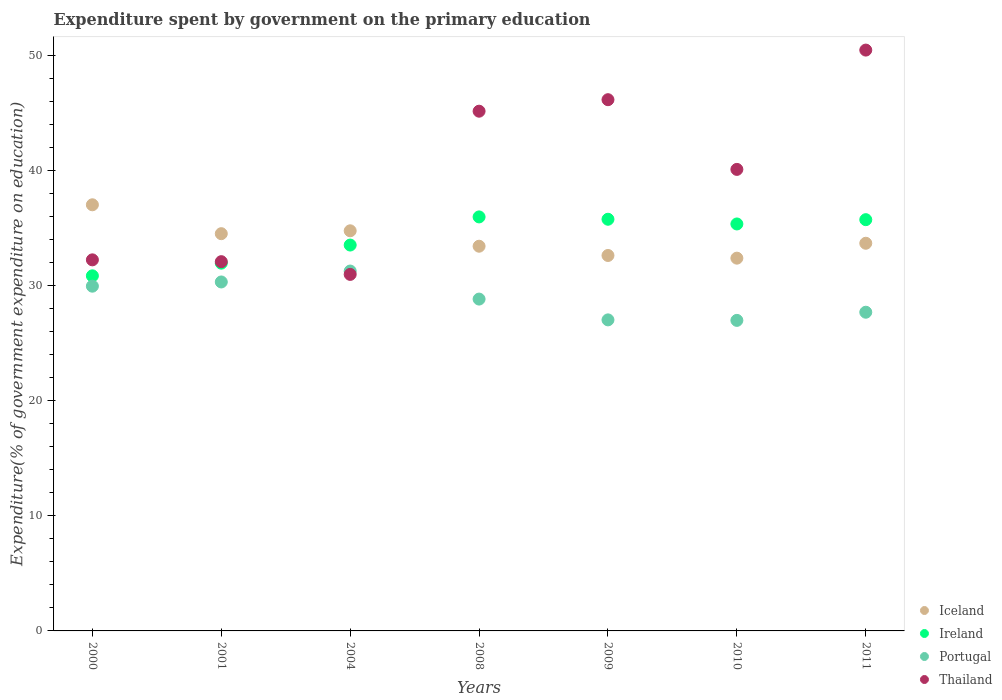What is the expenditure spent by government on the primary education in Ireland in 2004?
Offer a terse response. 33.51. Across all years, what is the maximum expenditure spent by government on the primary education in Iceland?
Your answer should be very brief. 37.01. Across all years, what is the minimum expenditure spent by government on the primary education in Thailand?
Ensure brevity in your answer.  30.97. In which year was the expenditure spent by government on the primary education in Iceland minimum?
Offer a terse response. 2010. What is the total expenditure spent by government on the primary education in Iceland in the graph?
Keep it short and to the point. 238.33. What is the difference between the expenditure spent by government on the primary education in Ireland in 2009 and that in 2010?
Your response must be concise. 0.41. What is the difference between the expenditure spent by government on the primary education in Portugal in 2009 and the expenditure spent by government on the primary education in Ireland in 2008?
Provide a short and direct response. -8.94. What is the average expenditure spent by government on the primary education in Portugal per year?
Your response must be concise. 28.86. In the year 2010, what is the difference between the expenditure spent by government on the primary education in Ireland and expenditure spent by government on the primary education in Thailand?
Provide a short and direct response. -4.74. What is the ratio of the expenditure spent by government on the primary education in Thailand in 2000 to that in 2008?
Make the answer very short. 0.71. Is the expenditure spent by government on the primary education in Portugal in 2000 less than that in 2008?
Offer a terse response. No. What is the difference between the highest and the second highest expenditure spent by government on the primary education in Ireland?
Your answer should be compact. 0.2. What is the difference between the highest and the lowest expenditure spent by government on the primary education in Thailand?
Offer a terse response. 19.48. In how many years, is the expenditure spent by government on the primary education in Ireland greater than the average expenditure spent by government on the primary education in Ireland taken over all years?
Your answer should be very brief. 4. Is the expenditure spent by government on the primary education in Iceland strictly greater than the expenditure spent by government on the primary education in Thailand over the years?
Keep it short and to the point. No. How many years are there in the graph?
Give a very brief answer. 7. Does the graph contain any zero values?
Your answer should be compact. No. Does the graph contain grids?
Provide a succinct answer. No. Where does the legend appear in the graph?
Your answer should be compact. Bottom right. How many legend labels are there?
Your answer should be very brief. 4. What is the title of the graph?
Keep it short and to the point. Expenditure spent by government on the primary education. Does "Romania" appear as one of the legend labels in the graph?
Provide a short and direct response. No. What is the label or title of the Y-axis?
Your answer should be compact. Expenditure(% of government expenditure on education). What is the Expenditure(% of government expenditure on education) in Iceland in 2000?
Offer a terse response. 37.01. What is the Expenditure(% of government expenditure on education) of Ireland in 2000?
Make the answer very short. 30.84. What is the Expenditure(% of government expenditure on education) in Portugal in 2000?
Provide a succinct answer. 29.94. What is the Expenditure(% of government expenditure on education) in Thailand in 2000?
Ensure brevity in your answer.  32.23. What is the Expenditure(% of government expenditure on education) in Iceland in 2001?
Ensure brevity in your answer.  34.5. What is the Expenditure(% of government expenditure on education) in Ireland in 2001?
Provide a succinct answer. 31.94. What is the Expenditure(% of government expenditure on education) of Portugal in 2001?
Your answer should be compact. 30.31. What is the Expenditure(% of government expenditure on education) of Thailand in 2001?
Provide a succinct answer. 32.07. What is the Expenditure(% of government expenditure on education) of Iceland in 2004?
Provide a succinct answer. 34.75. What is the Expenditure(% of government expenditure on education) in Ireland in 2004?
Make the answer very short. 33.51. What is the Expenditure(% of government expenditure on education) in Portugal in 2004?
Keep it short and to the point. 31.26. What is the Expenditure(% of government expenditure on education) in Thailand in 2004?
Offer a terse response. 30.97. What is the Expenditure(% of government expenditure on education) of Iceland in 2008?
Provide a short and direct response. 33.41. What is the Expenditure(% of government expenditure on education) of Ireland in 2008?
Your answer should be compact. 35.96. What is the Expenditure(% of government expenditure on education) of Portugal in 2008?
Provide a succinct answer. 28.82. What is the Expenditure(% of government expenditure on education) of Thailand in 2008?
Make the answer very short. 45.14. What is the Expenditure(% of government expenditure on education) in Iceland in 2009?
Offer a very short reply. 32.61. What is the Expenditure(% of government expenditure on education) in Ireland in 2009?
Offer a very short reply. 35.75. What is the Expenditure(% of government expenditure on education) of Portugal in 2009?
Your answer should be compact. 27.02. What is the Expenditure(% of government expenditure on education) of Thailand in 2009?
Make the answer very short. 46.14. What is the Expenditure(% of government expenditure on education) in Iceland in 2010?
Your answer should be compact. 32.38. What is the Expenditure(% of government expenditure on education) of Ireland in 2010?
Keep it short and to the point. 35.35. What is the Expenditure(% of government expenditure on education) of Portugal in 2010?
Offer a very short reply. 26.97. What is the Expenditure(% of government expenditure on education) of Thailand in 2010?
Offer a very short reply. 40.08. What is the Expenditure(% of government expenditure on education) in Iceland in 2011?
Provide a short and direct response. 33.67. What is the Expenditure(% of government expenditure on education) in Ireland in 2011?
Provide a succinct answer. 35.72. What is the Expenditure(% of government expenditure on education) in Portugal in 2011?
Your response must be concise. 27.68. What is the Expenditure(% of government expenditure on education) in Thailand in 2011?
Offer a terse response. 50.45. Across all years, what is the maximum Expenditure(% of government expenditure on education) in Iceland?
Your answer should be very brief. 37.01. Across all years, what is the maximum Expenditure(% of government expenditure on education) of Ireland?
Make the answer very short. 35.96. Across all years, what is the maximum Expenditure(% of government expenditure on education) in Portugal?
Provide a short and direct response. 31.26. Across all years, what is the maximum Expenditure(% of government expenditure on education) of Thailand?
Your answer should be compact. 50.45. Across all years, what is the minimum Expenditure(% of government expenditure on education) in Iceland?
Your answer should be very brief. 32.38. Across all years, what is the minimum Expenditure(% of government expenditure on education) in Ireland?
Your response must be concise. 30.84. Across all years, what is the minimum Expenditure(% of government expenditure on education) in Portugal?
Keep it short and to the point. 26.97. Across all years, what is the minimum Expenditure(% of government expenditure on education) in Thailand?
Offer a terse response. 30.97. What is the total Expenditure(% of government expenditure on education) in Iceland in the graph?
Make the answer very short. 238.33. What is the total Expenditure(% of government expenditure on education) in Ireland in the graph?
Your answer should be very brief. 239.07. What is the total Expenditure(% of government expenditure on education) in Portugal in the graph?
Your answer should be compact. 201.99. What is the total Expenditure(% of government expenditure on education) of Thailand in the graph?
Make the answer very short. 277.07. What is the difference between the Expenditure(% of government expenditure on education) in Iceland in 2000 and that in 2001?
Your answer should be very brief. 2.51. What is the difference between the Expenditure(% of government expenditure on education) in Ireland in 2000 and that in 2001?
Provide a succinct answer. -1.1. What is the difference between the Expenditure(% of government expenditure on education) of Portugal in 2000 and that in 2001?
Your answer should be compact. -0.37. What is the difference between the Expenditure(% of government expenditure on education) of Thailand in 2000 and that in 2001?
Your response must be concise. 0.16. What is the difference between the Expenditure(% of government expenditure on education) of Iceland in 2000 and that in 2004?
Provide a succinct answer. 2.26. What is the difference between the Expenditure(% of government expenditure on education) in Ireland in 2000 and that in 2004?
Offer a terse response. -2.67. What is the difference between the Expenditure(% of government expenditure on education) in Portugal in 2000 and that in 2004?
Your response must be concise. -1.31. What is the difference between the Expenditure(% of government expenditure on education) in Thailand in 2000 and that in 2004?
Offer a very short reply. 1.26. What is the difference between the Expenditure(% of government expenditure on education) of Iceland in 2000 and that in 2008?
Ensure brevity in your answer.  3.6. What is the difference between the Expenditure(% of government expenditure on education) of Ireland in 2000 and that in 2008?
Offer a very short reply. -5.12. What is the difference between the Expenditure(% of government expenditure on education) of Portugal in 2000 and that in 2008?
Offer a very short reply. 1.12. What is the difference between the Expenditure(% of government expenditure on education) in Thailand in 2000 and that in 2008?
Give a very brief answer. -12.91. What is the difference between the Expenditure(% of government expenditure on education) in Iceland in 2000 and that in 2009?
Offer a very short reply. 4.4. What is the difference between the Expenditure(% of government expenditure on education) in Ireland in 2000 and that in 2009?
Provide a succinct answer. -4.91. What is the difference between the Expenditure(% of government expenditure on education) of Portugal in 2000 and that in 2009?
Make the answer very short. 2.93. What is the difference between the Expenditure(% of government expenditure on education) in Thailand in 2000 and that in 2009?
Your answer should be compact. -13.91. What is the difference between the Expenditure(% of government expenditure on education) in Iceland in 2000 and that in 2010?
Provide a short and direct response. 4.64. What is the difference between the Expenditure(% of government expenditure on education) in Ireland in 2000 and that in 2010?
Make the answer very short. -4.5. What is the difference between the Expenditure(% of government expenditure on education) in Portugal in 2000 and that in 2010?
Provide a succinct answer. 2.97. What is the difference between the Expenditure(% of government expenditure on education) of Thailand in 2000 and that in 2010?
Your answer should be compact. -7.86. What is the difference between the Expenditure(% of government expenditure on education) in Iceland in 2000 and that in 2011?
Offer a very short reply. 3.34. What is the difference between the Expenditure(% of government expenditure on education) of Ireland in 2000 and that in 2011?
Provide a succinct answer. -4.88. What is the difference between the Expenditure(% of government expenditure on education) in Portugal in 2000 and that in 2011?
Offer a terse response. 2.26. What is the difference between the Expenditure(% of government expenditure on education) of Thailand in 2000 and that in 2011?
Your response must be concise. -18.22. What is the difference between the Expenditure(% of government expenditure on education) of Iceland in 2001 and that in 2004?
Keep it short and to the point. -0.25. What is the difference between the Expenditure(% of government expenditure on education) in Ireland in 2001 and that in 2004?
Offer a very short reply. -1.57. What is the difference between the Expenditure(% of government expenditure on education) in Portugal in 2001 and that in 2004?
Offer a very short reply. -0.95. What is the difference between the Expenditure(% of government expenditure on education) in Thailand in 2001 and that in 2004?
Make the answer very short. 1.11. What is the difference between the Expenditure(% of government expenditure on education) of Iceland in 2001 and that in 2008?
Your answer should be compact. 1.09. What is the difference between the Expenditure(% of government expenditure on education) in Ireland in 2001 and that in 2008?
Your answer should be very brief. -4.02. What is the difference between the Expenditure(% of government expenditure on education) in Portugal in 2001 and that in 2008?
Offer a terse response. 1.49. What is the difference between the Expenditure(% of government expenditure on education) of Thailand in 2001 and that in 2008?
Your response must be concise. -13.07. What is the difference between the Expenditure(% of government expenditure on education) of Iceland in 2001 and that in 2009?
Your answer should be compact. 1.89. What is the difference between the Expenditure(% of government expenditure on education) of Ireland in 2001 and that in 2009?
Give a very brief answer. -3.81. What is the difference between the Expenditure(% of government expenditure on education) of Portugal in 2001 and that in 2009?
Your answer should be very brief. 3.29. What is the difference between the Expenditure(% of government expenditure on education) of Thailand in 2001 and that in 2009?
Keep it short and to the point. -14.07. What is the difference between the Expenditure(% of government expenditure on education) of Iceland in 2001 and that in 2010?
Keep it short and to the point. 2.13. What is the difference between the Expenditure(% of government expenditure on education) of Ireland in 2001 and that in 2010?
Make the answer very short. -3.4. What is the difference between the Expenditure(% of government expenditure on education) in Portugal in 2001 and that in 2010?
Offer a very short reply. 3.34. What is the difference between the Expenditure(% of government expenditure on education) of Thailand in 2001 and that in 2010?
Make the answer very short. -8.01. What is the difference between the Expenditure(% of government expenditure on education) in Iceland in 2001 and that in 2011?
Provide a short and direct response. 0.83. What is the difference between the Expenditure(% of government expenditure on education) of Ireland in 2001 and that in 2011?
Keep it short and to the point. -3.78. What is the difference between the Expenditure(% of government expenditure on education) of Portugal in 2001 and that in 2011?
Provide a short and direct response. 2.63. What is the difference between the Expenditure(% of government expenditure on education) of Thailand in 2001 and that in 2011?
Offer a terse response. -18.38. What is the difference between the Expenditure(% of government expenditure on education) of Iceland in 2004 and that in 2008?
Your response must be concise. 1.34. What is the difference between the Expenditure(% of government expenditure on education) of Ireland in 2004 and that in 2008?
Provide a short and direct response. -2.44. What is the difference between the Expenditure(% of government expenditure on education) in Portugal in 2004 and that in 2008?
Give a very brief answer. 2.44. What is the difference between the Expenditure(% of government expenditure on education) of Thailand in 2004 and that in 2008?
Provide a succinct answer. -14.17. What is the difference between the Expenditure(% of government expenditure on education) in Iceland in 2004 and that in 2009?
Your answer should be compact. 2.14. What is the difference between the Expenditure(% of government expenditure on education) of Ireland in 2004 and that in 2009?
Your response must be concise. -2.24. What is the difference between the Expenditure(% of government expenditure on education) in Portugal in 2004 and that in 2009?
Give a very brief answer. 4.24. What is the difference between the Expenditure(% of government expenditure on education) of Thailand in 2004 and that in 2009?
Your answer should be compact. -15.17. What is the difference between the Expenditure(% of government expenditure on education) in Iceland in 2004 and that in 2010?
Keep it short and to the point. 2.38. What is the difference between the Expenditure(% of government expenditure on education) of Ireland in 2004 and that in 2010?
Provide a short and direct response. -1.83. What is the difference between the Expenditure(% of government expenditure on education) of Portugal in 2004 and that in 2010?
Keep it short and to the point. 4.29. What is the difference between the Expenditure(% of government expenditure on education) in Thailand in 2004 and that in 2010?
Your answer should be very brief. -9.12. What is the difference between the Expenditure(% of government expenditure on education) of Iceland in 2004 and that in 2011?
Your response must be concise. 1.08. What is the difference between the Expenditure(% of government expenditure on education) of Ireland in 2004 and that in 2011?
Offer a terse response. -2.2. What is the difference between the Expenditure(% of government expenditure on education) of Portugal in 2004 and that in 2011?
Provide a succinct answer. 3.58. What is the difference between the Expenditure(% of government expenditure on education) in Thailand in 2004 and that in 2011?
Your response must be concise. -19.48. What is the difference between the Expenditure(% of government expenditure on education) in Iceland in 2008 and that in 2009?
Make the answer very short. 0.8. What is the difference between the Expenditure(% of government expenditure on education) in Ireland in 2008 and that in 2009?
Your response must be concise. 0.2. What is the difference between the Expenditure(% of government expenditure on education) of Portugal in 2008 and that in 2009?
Keep it short and to the point. 1.81. What is the difference between the Expenditure(% of government expenditure on education) in Thailand in 2008 and that in 2009?
Offer a very short reply. -1. What is the difference between the Expenditure(% of government expenditure on education) in Iceland in 2008 and that in 2010?
Ensure brevity in your answer.  1.04. What is the difference between the Expenditure(% of government expenditure on education) in Ireland in 2008 and that in 2010?
Keep it short and to the point. 0.61. What is the difference between the Expenditure(% of government expenditure on education) in Portugal in 2008 and that in 2010?
Offer a terse response. 1.85. What is the difference between the Expenditure(% of government expenditure on education) in Thailand in 2008 and that in 2010?
Make the answer very short. 5.05. What is the difference between the Expenditure(% of government expenditure on education) in Iceland in 2008 and that in 2011?
Your response must be concise. -0.26. What is the difference between the Expenditure(% of government expenditure on education) of Ireland in 2008 and that in 2011?
Your answer should be very brief. 0.24. What is the difference between the Expenditure(% of government expenditure on education) of Portugal in 2008 and that in 2011?
Offer a terse response. 1.14. What is the difference between the Expenditure(% of government expenditure on education) of Thailand in 2008 and that in 2011?
Offer a terse response. -5.31. What is the difference between the Expenditure(% of government expenditure on education) of Iceland in 2009 and that in 2010?
Make the answer very short. 0.23. What is the difference between the Expenditure(% of government expenditure on education) of Ireland in 2009 and that in 2010?
Give a very brief answer. 0.41. What is the difference between the Expenditure(% of government expenditure on education) in Portugal in 2009 and that in 2010?
Your response must be concise. 0.04. What is the difference between the Expenditure(% of government expenditure on education) in Thailand in 2009 and that in 2010?
Provide a short and direct response. 6.05. What is the difference between the Expenditure(% of government expenditure on education) of Iceland in 2009 and that in 2011?
Ensure brevity in your answer.  -1.06. What is the difference between the Expenditure(% of government expenditure on education) of Ireland in 2009 and that in 2011?
Provide a short and direct response. 0.04. What is the difference between the Expenditure(% of government expenditure on education) in Portugal in 2009 and that in 2011?
Make the answer very short. -0.66. What is the difference between the Expenditure(% of government expenditure on education) of Thailand in 2009 and that in 2011?
Give a very brief answer. -4.31. What is the difference between the Expenditure(% of government expenditure on education) of Iceland in 2010 and that in 2011?
Offer a very short reply. -1.29. What is the difference between the Expenditure(% of government expenditure on education) of Ireland in 2010 and that in 2011?
Offer a terse response. -0.37. What is the difference between the Expenditure(% of government expenditure on education) in Portugal in 2010 and that in 2011?
Provide a short and direct response. -0.71. What is the difference between the Expenditure(% of government expenditure on education) of Thailand in 2010 and that in 2011?
Keep it short and to the point. -10.36. What is the difference between the Expenditure(% of government expenditure on education) in Iceland in 2000 and the Expenditure(% of government expenditure on education) in Ireland in 2001?
Give a very brief answer. 5.07. What is the difference between the Expenditure(% of government expenditure on education) of Iceland in 2000 and the Expenditure(% of government expenditure on education) of Portugal in 2001?
Provide a succinct answer. 6.7. What is the difference between the Expenditure(% of government expenditure on education) of Iceland in 2000 and the Expenditure(% of government expenditure on education) of Thailand in 2001?
Offer a terse response. 4.94. What is the difference between the Expenditure(% of government expenditure on education) of Ireland in 2000 and the Expenditure(% of government expenditure on education) of Portugal in 2001?
Offer a terse response. 0.53. What is the difference between the Expenditure(% of government expenditure on education) in Ireland in 2000 and the Expenditure(% of government expenditure on education) in Thailand in 2001?
Provide a short and direct response. -1.23. What is the difference between the Expenditure(% of government expenditure on education) in Portugal in 2000 and the Expenditure(% of government expenditure on education) in Thailand in 2001?
Your answer should be compact. -2.13. What is the difference between the Expenditure(% of government expenditure on education) in Iceland in 2000 and the Expenditure(% of government expenditure on education) in Ireland in 2004?
Offer a very short reply. 3.5. What is the difference between the Expenditure(% of government expenditure on education) of Iceland in 2000 and the Expenditure(% of government expenditure on education) of Portugal in 2004?
Keep it short and to the point. 5.75. What is the difference between the Expenditure(% of government expenditure on education) of Iceland in 2000 and the Expenditure(% of government expenditure on education) of Thailand in 2004?
Keep it short and to the point. 6.05. What is the difference between the Expenditure(% of government expenditure on education) in Ireland in 2000 and the Expenditure(% of government expenditure on education) in Portugal in 2004?
Provide a succinct answer. -0.42. What is the difference between the Expenditure(% of government expenditure on education) of Ireland in 2000 and the Expenditure(% of government expenditure on education) of Thailand in 2004?
Your answer should be very brief. -0.12. What is the difference between the Expenditure(% of government expenditure on education) in Portugal in 2000 and the Expenditure(% of government expenditure on education) in Thailand in 2004?
Your answer should be compact. -1.02. What is the difference between the Expenditure(% of government expenditure on education) in Iceland in 2000 and the Expenditure(% of government expenditure on education) in Ireland in 2008?
Ensure brevity in your answer.  1.05. What is the difference between the Expenditure(% of government expenditure on education) of Iceland in 2000 and the Expenditure(% of government expenditure on education) of Portugal in 2008?
Your answer should be very brief. 8.19. What is the difference between the Expenditure(% of government expenditure on education) in Iceland in 2000 and the Expenditure(% of government expenditure on education) in Thailand in 2008?
Offer a very short reply. -8.13. What is the difference between the Expenditure(% of government expenditure on education) of Ireland in 2000 and the Expenditure(% of government expenditure on education) of Portugal in 2008?
Make the answer very short. 2.02. What is the difference between the Expenditure(% of government expenditure on education) in Ireland in 2000 and the Expenditure(% of government expenditure on education) in Thailand in 2008?
Keep it short and to the point. -14.3. What is the difference between the Expenditure(% of government expenditure on education) of Portugal in 2000 and the Expenditure(% of government expenditure on education) of Thailand in 2008?
Your response must be concise. -15.2. What is the difference between the Expenditure(% of government expenditure on education) of Iceland in 2000 and the Expenditure(% of government expenditure on education) of Ireland in 2009?
Keep it short and to the point. 1.26. What is the difference between the Expenditure(% of government expenditure on education) of Iceland in 2000 and the Expenditure(% of government expenditure on education) of Portugal in 2009?
Your response must be concise. 10. What is the difference between the Expenditure(% of government expenditure on education) of Iceland in 2000 and the Expenditure(% of government expenditure on education) of Thailand in 2009?
Offer a very short reply. -9.13. What is the difference between the Expenditure(% of government expenditure on education) in Ireland in 2000 and the Expenditure(% of government expenditure on education) in Portugal in 2009?
Give a very brief answer. 3.83. What is the difference between the Expenditure(% of government expenditure on education) of Ireland in 2000 and the Expenditure(% of government expenditure on education) of Thailand in 2009?
Provide a succinct answer. -15.3. What is the difference between the Expenditure(% of government expenditure on education) of Portugal in 2000 and the Expenditure(% of government expenditure on education) of Thailand in 2009?
Keep it short and to the point. -16.2. What is the difference between the Expenditure(% of government expenditure on education) in Iceland in 2000 and the Expenditure(% of government expenditure on education) in Ireland in 2010?
Your answer should be compact. 1.67. What is the difference between the Expenditure(% of government expenditure on education) of Iceland in 2000 and the Expenditure(% of government expenditure on education) of Portugal in 2010?
Keep it short and to the point. 10.04. What is the difference between the Expenditure(% of government expenditure on education) of Iceland in 2000 and the Expenditure(% of government expenditure on education) of Thailand in 2010?
Your answer should be compact. -3.07. What is the difference between the Expenditure(% of government expenditure on education) of Ireland in 2000 and the Expenditure(% of government expenditure on education) of Portugal in 2010?
Your answer should be compact. 3.87. What is the difference between the Expenditure(% of government expenditure on education) in Ireland in 2000 and the Expenditure(% of government expenditure on education) in Thailand in 2010?
Keep it short and to the point. -9.24. What is the difference between the Expenditure(% of government expenditure on education) of Portugal in 2000 and the Expenditure(% of government expenditure on education) of Thailand in 2010?
Your answer should be very brief. -10.14. What is the difference between the Expenditure(% of government expenditure on education) of Iceland in 2000 and the Expenditure(% of government expenditure on education) of Ireland in 2011?
Your answer should be compact. 1.29. What is the difference between the Expenditure(% of government expenditure on education) of Iceland in 2000 and the Expenditure(% of government expenditure on education) of Portugal in 2011?
Keep it short and to the point. 9.33. What is the difference between the Expenditure(% of government expenditure on education) in Iceland in 2000 and the Expenditure(% of government expenditure on education) in Thailand in 2011?
Your response must be concise. -13.44. What is the difference between the Expenditure(% of government expenditure on education) in Ireland in 2000 and the Expenditure(% of government expenditure on education) in Portugal in 2011?
Give a very brief answer. 3.16. What is the difference between the Expenditure(% of government expenditure on education) in Ireland in 2000 and the Expenditure(% of government expenditure on education) in Thailand in 2011?
Keep it short and to the point. -19.61. What is the difference between the Expenditure(% of government expenditure on education) in Portugal in 2000 and the Expenditure(% of government expenditure on education) in Thailand in 2011?
Keep it short and to the point. -20.5. What is the difference between the Expenditure(% of government expenditure on education) of Iceland in 2001 and the Expenditure(% of government expenditure on education) of Ireland in 2004?
Your response must be concise. 0.99. What is the difference between the Expenditure(% of government expenditure on education) in Iceland in 2001 and the Expenditure(% of government expenditure on education) in Portugal in 2004?
Offer a terse response. 3.25. What is the difference between the Expenditure(% of government expenditure on education) in Iceland in 2001 and the Expenditure(% of government expenditure on education) in Thailand in 2004?
Make the answer very short. 3.54. What is the difference between the Expenditure(% of government expenditure on education) of Ireland in 2001 and the Expenditure(% of government expenditure on education) of Portugal in 2004?
Your answer should be compact. 0.68. What is the difference between the Expenditure(% of government expenditure on education) of Ireland in 2001 and the Expenditure(% of government expenditure on education) of Thailand in 2004?
Your response must be concise. 0.98. What is the difference between the Expenditure(% of government expenditure on education) in Portugal in 2001 and the Expenditure(% of government expenditure on education) in Thailand in 2004?
Make the answer very short. -0.66. What is the difference between the Expenditure(% of government expenditure on education) of Iceland in 2001 and the Expenditure(% of government expenditure on education) of Ireland in 2008?
Provide a succinct answer. -1.46. What is the difference between the Expenditure(% of government expenditure on education) in Iceland in 2001 and the Expenditure(% of government expenditure on education) in Portugal in 2008?
Ensure brevity in your answer.  5.68. What is the difference between the Expenditure(% of government expenditure on education) of Iceland in 2001 and the Expenditure(% of government expenditure on education) of Thailand in 2008?
Give a very brief answer. -10.64. What is the difference between the Expenditure(% of government expenditure on education) in Ireland in 2001 and the Expenditure(% of government expenditure on education) in Portugal in 2008?
Your answer should be very brief. 3.12. What is the difference between the Expenditure(% of government expenditure on education) in Ireland in 2001 and the Expenditure(% of government expenditure on education) in Thailand in 2008?
Keep it short and to the point. -13.2. What is the difference between the Expenditure(% of government expenditure on education) in Portugal in 2001 and the Expenditure(% of government expenditure on education) in Thailand in 2008?
Your answer should be compact. -14.83. What is the difference between the Expenditure(% of government expenditure on education) in Iceland in 2001 and the Expenditure(% of government expenditure on education) in Ireland in 2009?
Provide a succinct answer. -1.25. What is the difference between the Expenditure(% of government expenditure on education) of Iceland in 2001 and the Expenditure(% of government expenditure on education) of Portugal in 2009?
Make the answer very short. 7.49. What is the difference between the Expenditure(% of government expenditure on education) in Iceland in 2001 and the Expenditure(% of government expenditure on education) in Thailand in 2009?
Provide a succinct answer. -11.64. What is the difference between the Expenditure(% of government expenditure on education) of Ireland in 2001 and the Expenditure(% of government expenditure on education) of Portugal in 2009?
Offer a very short reply. 4.93. What is the difference between the Expenditure(% of government expenditure on education) of Ireland in 2001 and the Expenditure(% of government expenditure on education) of Thailand in 2009?
Make the answer very short. -14.2. What is the difference between the Expenditure(% of government expenditure on education) in Portugal in 2001 and the Expenditure(% of government expenditure on education) in Thailand in 2009?
Provide a succinct answer. -15.83. What is the difference between the Expenditure(% of government expenditure on education) of Iceland in 2001 and the Expenditure(% of government expenditure on education) of Ireland in 2010?
Your response must be concise. -0.84. What is the difference between the Expenditure(% of government expenditure on education) of Iceland in 2001 and the Expenditure(% of government expenditure on education) of Portugal in 2010?
Provide a short and direct response. 7.53. What is the difference between the Expenditure(% of government expenditure on education) in Iceland in 2001 and the Expenditure(% of government expenditure on education) in Thailand in 2010?
Give a very brief answer. -5.58. What is the difference between the Expenditure(% of government expenditure on education) in Ireland in 2001 and the Expenditure(% of government expenditure on education) in Portugal in 2010?
Give a very brief answer. 4.97. What is the difference between the Expenditure(% of government expenditure on education) of Ireland in 2001 and the Expenditure(% of government expenditure on education) of Thailand in 2010?
Make the answer very short. -8.14. What is the difference between the Expenditure(% of government expenditure on education) in Portugal in 2001 and the Expenditure(% of government expenditure on education) in Thailand in 2010?
Your answer should be compact. -9.78. What is the difference between the Expenditure(% of government expenditure on education) of Iceland in 2001 and the Expenditure(% of government expenditure on education) of Ireland in 2011?
Your answer should be compact. -1.22. What is the difference between the Expenditure(% of government expenditure on education) of Iceland in 2001 and the Expenditure(% of government expenditure on education) of Portugal in 2011?
Give a very brief answer. 6.82. What is the difference between the Expenditure(% of government expenditure on education) in Iceland in 2001 and the Expenditure(% of government expenditure on education) in Thailand in 2011?
Make the answer very short. -15.95. What is the difference between the Expenditure(% of government expenditure on education) in Ireland in 2001 and the Expenditure(% of government expenditure on education) in Portugal in 2011?
Provide a succinct answer. 4.26. What is the difference between the Expenditure(% of government expenditure on education) of Ireland in 2001 and the Expenditure(% of government expenditure on education) of Thailand in 2011?
Your response must be concise. -18.51. What is the difference between the Expenditure(% of government expenditure on education) of Portugal in 2001 and the Expenditure(% of government expenditure on education) of Thailand in 2011?
Your response must be concise. -20.14. What is the difference between the Expenditure(% of government expenditure on education) of Iceland in 2004 and the Expenditure(% of government expenditure on education) of Ireland in 2008?
Keep it short and to the point. -1.21. What is the difference between the Expenditure(% of government expenditure on education) in Iceland in 2004 and the Expenditure(% of government expenditure on education) in Portugal in 2008?
Keep it short and to the point. 5.93. What is the difference between the Expenditure(% of government expenditure on education) in Iceland in 2004 and the Expenditure(% of government expenditure on education) in Thailand in 2008?
Provide a succinct answer. -10.39. What is the difference between the Expenditure(% of government expenditure on education) of Ireland in 2004 and the Expenditure(% of government expenditure on education) of Portugal in 2008?
Your answer should be very brief. 4.69. What is the difference between the Expenditure(% of government expenditure on education) of Ireland in 2004 and the Expenditure(% of government expenditure on education) of Thailand in 2008?
Offer a terse response. -11.63. What is the difference between the Expenditure(% of government expenditure on education) in Portugal in 2004 and the Expenditure(% of government expenditure on education) in Thailand in 2008?
Make the answer very short. -13.88. What is the difference between the Expenditure(% of government expenditure on education) of Iceland in 2004 and the Expenditure(% of government expenditure on education) of Ireland in 2009?
Provide a short and direct response. -1. What is the difference between the Expenditure(% of government expenditure on education) of Iceland in 2004 and the Expenditure(% of government expenditure on education) of Portugal in 2009?
Offer a very short reply. 7.74. What is the difference between the Expenditure(% of government expenditure on education) in Iceland in 2004 and the Expenditure(% of government expenditure on education) in Thailand in 2009?
Your response must be concise. -11.39. What is the difference between the Expenditure(% of government expenditure on education) in Ireland in 2004 and the Expenditure(% of government expenditure on education) in Portugal in 2009?
Offer a very short reply. 6.5. What is the difference between the Expenditure(% of government expenditure on education) of Ireland in 2004 and the Expenditure(% of government expenditure on education) of Thailand in 2009?
Your answer should be compact. -12.62. What is the difference between the Expenditure(% of government expenditure on education) in Portugal in 2004 and the Expenditure(% of government expenditure on education) in Thailand in 2009?
Keep it short and to the point. -14.88. What is the difference between the Expenditure(% of government expenditure on education) of Iceland in 2004 and the Expenditure(% of government expenditure on education) of Ireland in 2010?
Ensure brevity in your answer.  -0.59. What is the difference between the Expenditure(% of government expenditure on education) in Iceland in 2004 and the Expenditure(% of government expenditure on education) in Portugal in 2010?
Keep it short and to the point. 7.78. What is the difference between the Expenditure(% of government expenditure on education) of Iceland in 2004 and the Expenditure(% of government expenditure on education) of Thailand in 2010?
Make the answer very short. -5.33. What is the difference between the Expenditure(% of government expenditure on education) of Ireland in 2004 and the Expenditure(% of government expenditure on education) of Portugal in 2010?
Keep it short and to the point. 6.54. What is the difference between the Expenditure(% of government expenditure on education) in Ireland in 2004 and the Expenditure(% of government expenditure on education) in Thailand in 2010?
Your answer should be very brief. -6.57. What is the difference between the Expenditure(% of government expenditure on education) in Portugal in 2004 and the Expenditure(% of government expenditure on education) in Thailand in 2010?
Keep it short and to the point. -8.83. What is the difference between the Expenditure(% of government expenditure on education) of Iceland in 2004 and the Expenditure(% of government expenditure on education) of Ireland in 2011?
Provide a short and direct response. -0.97. What is the difference between the Expenditure(% of government expenditure on education) of Iceland in 2004 and the Expenditure(% of government expenditure on education) of Portugal in 2011?
Ensure brevity in your answer.  7.07. What is the difference between the Expenditure(% of government expenditure on education) of Iceland in 2004 and the Expenditure(% of government expenditure on education) of Thailand in 2011?
Your response must be concise. -15.7. What is the difference between the Expenditure(% of government expenditure on education) in Ireland in 2004 and the Expenditure(% of government expenditure on education) in Portugal in 2011?
Offer a terse response. 5.83. What is the difference between the Expenditure(% of government expenditure on education) in Ireland in 2004 and the Expenditure(% of government expenditure on education) in Thailand in 2011?
Give a very brief answer. -16.93. What is the difference between the Expenditure(% of government expenditure on education) in Portugal in 2004 and the Expenditure(% of government expenditure on education) in Thailand in 2011?
Your response must be concise. -19.19. What is the difference between the Expenditure(% of government expenditure on education) in Iceland in 2008 and the Expenditure(% of government expenditure on education) in Ireland in 2009?
Offer a terse response. -2.34. What is the difference between the Expenditure(% of government expenditure on education) of Iceland in 2008 and the Expenditure(% of government expenditure on education) of Portugal in 2009?
Offer a very short reply. 6.4. What is the difference between the Expenditure(% of government expenditure on education) of Iceland in 2008 and the Expenditure(% of government expenditure on education) of Thailand in 2009?
Provide a succinct answer. -12.73. What is the difference between the Expenditure(% of government expenditure on education) of Ireland in 2008 and the Expenditure(% of government expenditure on education) of Portugal in 2009?
Keep it short and to the point. 8.94. What is the difference between the Expenditure(% of government expenditure on education) of Ireland in 2008 and the Expenditure(% of government expenditure on education) of Thailand in 2009?
Provide a succinct answer. -10.18. What is the difference between the Expenditure(% of government expenditure on education) of Portugal in 2008 and the Expenditure(% of government expenditure on education) of Thailand in 2009?
Offer a terse response. -17.32. What is the difference between the Expenditure(% of government expenditure on education) in Iceland in 2008 and the Expenditure(% of government expenditure on education) in Ireland in 2010?
Offer a terse response. -1.93. What is the difference between the Expenditure(% of government expenditure on education) in Iceland in 2008 and the Expenditure(% of government expenditure on education) in Portugal in 2010?
Your response must be concise. 6.44. What is the difference between the Expenditure(% of government expenditure on education) of Iceland in 2008 and the Expenditure(% of government expenditure on education) of Thailand in 2010?
Give a very brief answer. -6.67. What is the difference between the Expenditure(% of government expenditure on education) in Ireland in 2008 and the Expenditure(% of government expenditure on education) in Portugal in 2010?
Provide a succinct answer. 8.99. What is the difference between the Expenditure(% of government expenditure on education) in Ireland in 2008 and the Expenditure(% of government expenditure on education) in Thailand in 2010?
Give a very brief answer. -4.13. What is the difference between the Expenditure(% of government expenditure on education) in Portugal in 2008 and the Expenditure(% of government expenditure on education) in Thailand in 2010?
Your answer should be compact. -11.26. What is the difference between the Expenditure(% of government expenditure on education) of Iceland in 2008 and the Expenditure(% of government expenditure on education) of Ireland in 2011?
Offer a very short reply. -2.31. What is the difference between the Expenditure(% of government expenditure on education) of Iceland in 2008 and the Expenditure(% of government expenditure on education) of Portugal in 2011?
Ensure brevity in your answer.  5.73. What is the difference between the Expenditure(% of government expenditure on education) in Iceland in 2008 and the Expenditure(% of government expenditure on education) in Thailand in 2011?
Provide a short and direct response. -17.03. What is the difference between the Expenditure(% of government expenditure on education) of Ireland in 2008 and the Expenditure(% of government expenditure on education) of Portugal in 2011?
Provide a short and direct response. 8.28. What is the difference between the Expenditure(% of government expenditure on education) in Ireland in 2008 and the Expenditure(% of government expenditure on education) in Thailand in 2011?
Your answer should be very brief. -14.49. What is the difference between the Expenditure(% of government expenditure on education) of Portugal in 2008 and the Expenditure(% of government expenditure on education) of Thailand in 2011?
Offer a terse response. -21.63. What is the difference between the Expenditure(% of government expenditure on education) of Iceland in 2009 and the Expenditure(% of government expenditure on education) of Ireland in 2010?
Your answer should be very brief. -2.74. What is the difference between the Expenditure(% of government expenditure on education) in Iceland in 2009 and the Expenditure(% of government expenditure on education) in Portugal in 2010?
Your answer should be compact. 5.64. What is the difference between the Expenditure(% of government expenditure on education) in Iceland in 2009 and the Expenditure(% of government expenditure on education) in Thailand in 2010?
Ensure brevity in your answer.  -7.48. What is the difference between the Expenditure(% of government expenditure on education) in Ireland in 2009 and the Expenditure(% of government expenditure on education) in Portugal in 2010?
Give a very brief answer. 8.78. What is the difference between the Expenditure(% of government expenditure on education) of Ireland in 2009 and the Expenditure(% of government expenditure on education) of Thailand in 2010?
Provide a succinct answer. -4.33. What is the difference between the Expenditure(% of government expenditure on education) in Portugal in 2009 and the Expenditure(% of government expenditure on education) in Thailand in 2010?
Provide a short and direct response. -13.07. What is the difference between the Expenditure(% of government expenditure on education) of Iceland in 2009 and the Expenditure(% of government expenditure on education) of Ireland in 2011?
Your answer should be compact. -3.11. What is the difference between the Expenditure(% of government expenditure on education) in Iceland in 2009 and the Expenditure(% of government expenditure on education) in Portugal in 2011?
Your response must be concise. 4.93. What is the difference between the Expenditure(% of government expenditure on education) in Iceland in 2009 and the Expenditure(% of government expenditure on education) in Thailand in 2011?
Your answer should be compact. -17.84. What is the difference between the Expenditure(% of government expenditure on education) in Ireland in 2009 and the Expenditure(% of government expenditure on education) in Portugal in 2011?
Make the answer very short. 8.07. What is the difference between the Expenditure(% of government expenditure on education) in Ireland in 2009 and the Expenditure(% of government expenditure on education) in Thailand in 2011?
Your response must be concise. -14.69. What is the difference between the Expenditure(% of government expenditure on education) of Portugal in 2009 and the Expenditure(% of government expenditure on education) of Thailand in 2011?
Provide a short and direct response. -23.43. What is the difference between the Expenditure(% of government expenditure on education) in Iceland in 2010 and the Expenditure(% of government expenditure on education) in Ireland in 2011?
Your answer should be compact. -3.34. What is the difference between the Expenditure(% of government expenditure on education) in Iceland in 2010 and the Expenditure(% of government expenditure on education) in Portugal in 2011?
Give a very brief answer. 4.7. What is the difference between the Expenditure(% of government expenditure on education) of Iceland in 2010 and the Expenditure(% of government expenditure on education) of Thailand in 2011?
Your answer should be compact. -18.07. What is the difference between the Expenditure(% of government expenditure on education) in Ireland in 2010 and the Expenditure(% of government expenditure on education) in Portugal in 2011?
Your answer should be compact. 7.67. What is the difference between the Expenditure(% of government expenditure on education) in Ireland in 2010 and the Expenditure(% of government expenditure on education) in Thailand in 2011?
Offer a terse response. -15.1. What is the difference between the Expenditure(% of government expenditure on education) of Portugal in 2010 and the Expenditure(% of government expenditure on education) of Thailand in 2011?
Your answer should be compact. -23.48. What is the average Expenditure(% of government expenditure on education) of Iceland per year?
Make the answer very short. 34.05. What is the average Expenditure(% of government expenditure on education) of Ireland per year?
Offer a very short reply. 34.15. What is the average Expenditure(% of government expenditure on education) of Portugal per year?
Give a very brief answer. 28.86. What is the average Expenditure(% of government expenditure on education) of Thailand per year?
Make the answer very short. 39.58. In the year 2000, what is the difference between the Expenditure(% of government expenditure on education) in Iceland and Expenditure(% of government expenditure on education) in Ireland?
Offer a very short reply. 6.17. In the year 2000, what is the difference between the Expenditure(% of government expenditure on education) in Iceland and Expenditure(% of government expenditure on education) in Portugal?
Offer a terse response. 7.07. In the year 2000, what is the difference between the Expenditure(% of government expenditure on education) of Iceland and Expenditure(% of government expenditure on education) of Thailand?
Offer a terse response. 4.78. In the year 2000, what is the difference between the Expenditure(% of government expenditure on education) of Ireland and Expenditure(% of government expenditure on education) of Portugal?
Your response must be concise. 0.9. In the year 2000, what is the difference between the Expenditure(% of government expenditure on education) in Ireland and Expenditure(% of government expenditure on education) in Thailand?
Your answer should be very brief. -1.39. In the year 2000, what is the difference between the Expenditure(% of government expenditure on education) in Portugal and Expenditure(% of government expenditure on education) in Thailand?
Your response must be concise. -2.29. In the year 2001, what is the difference between the Expenditure(% of government expenditure on education) of Iceland and Expenditure(% of government expenditure on education) of Ireland?
Your answer should be very brief. 2.56. In the year 2001, what is the difference between the Expenditure(% of government expenditure on education) of Iceland and Expenditure(% of government expenditure on education) of Portugal?
Offer a very short reply. 4.19. In the year 2001, what is the difference between the Expenditure(% of government expenditure on education) in Iceland and Expenditure(% of government expenditure on education) in Thailand?
Make the answer very short. 2.43. In the year 2001, what is the difference between the Expenditure(% of government expenditure on education) of Ireland and Expenditure(% of government expenditure on education) of Portugal?
Keep it short and to the point. 1.63. In the year 2001, what is the difference between the Expenditure(% of government expenditure on education) of Ireland and Expenditure(% of government expenditure on education) of Thailand?
Ensure brevity in your answer.  -0.13. In the year 2001, what is the difference between the Expenditure(% of government expenditure on education) in Portugal and Expenditure(% of government expenditure on education) in Thailand?
Give a very brief answer. -1.76. In the year 2004, what is the difference between the Expenditure(% of government expenditure on education) of Iceland and Expenditure(% of government expenditure on education) of Ireland?
Make the answer very short. 1.24. In the year 2004, what is the difference between the Expenditure(% of government expenditure on education) of Iceland and Expenditure(% of government expenditure on education) of Portugal?
Keep it short and to the point. 3.49. In the year 2004, what is the difference between the Expenditure(% of government expenditure on education) in Iceland and Expenditure(% of government expenditure on education) in Thailand?
Give a very brief answer. 3.79. In the year 2004, what is the difference between the Expenditure(% of government expenditure on education) of Ireland and Expenditure(% of government expenditure on education) of Portugal?
Ensure brevity in your answer.  2.26. In the year 2004, what is the difference between the Expenditure(% of government expenditure on education) of Ireland and Expenditure(% of government expenditure on education) of Thailand?
Provide a succinct answer. 2.55. In the year 2004, what is the difference between the Expenditure(% of government expenditure on education) in Portugal and Expenditure(% of government expenditure on education) in Thailand?
Keep it short and to the point. 0.29. In the year 2008, what is the difference between the Expenditure(% of government expenditure on education) in Iceland and Expenditure(% of government expenditure on education) in Ireland?
Provide a short and direct response. -2.55. In the year 2008, what is the difference between the Expenditure(% of government expenditure on education) of Iceland and Expenditure(% of government expenditure on education) of Portugal?
Your answer should be compact. 4.59. In the year 2008, what is the difference between the Expenditure(% of government expenditure on education) in Iceland and Expenditure(% of government expenditure on education) in Thailand?
Your answer should be compact. -11.73. In the year 2008, what is the difference between the Expenditure(% of government expenditure on education) in Ireland and Expenditure(% of government expenditure on education) in Portugal?
Ensure brevity in your answer.  7.14. In the year 2008, what is the difference between the Expenditure(% of government expenditure on education) of Ireland and Expenditure(% of government expenditure on education) of Thailand?
Ensure brevity in your answer.  -9.18. In the year 2008, what is the difference between the Expenditure(% of government expenditure on education) of Portugal and Expenditure(% of government expenditure on education) of Thailand?
Offer a terse response. -16.32. In the year 2009, what is the difference between the Expenditure(% of government expenditure on education) of Iceland and Expenditure(% of government expenditure on education) of Ireland?
Your answer should be very brief. -3.15. In the year 2009, what is the difference between the Expenditure(% of government expenditure on education) of Iceland and Expenditure(% of government expenditure on education) of Portugal?
Offer a terse response. 5.59. In the year 2009, what is the difference between the Expenditure(% of government expenditure on education) in Iceland and Expenditure(% of government expenditure on education) in Thailand?
Ensure brevity in your answer.  -13.53. In the year 2009, what is the difference between the Expenditure(% of government expenditure on education) of Ireland and Expenditure(% of government expenditure on education) of Portugal?
Keep it short and to the point. 8.74. In the year 2009, what is the difference between the Expenditure(% of government expenditure on education) in Ireland and Expenditure(% of government expenditure on education) in Thailand?
Ensure brevity in your answer.  -10.38. In the year 2009, what is the difference between the Expenditure(% of government expenditure on education) of Portugal and Expenditure(% of government expenditure on education) of Thailand?
Your answer should be very brief. -19.12. In the year 2010, what is the difference between the Expenditure(% of government expenditure on education) in Iceland and Expenditure(% of government expenditure on education) in Ireland?
Your answer should be very brief. -2.97. In the year 2010, what is the difference between the Expenditure(% of government expenditure on education) of Iceland and Expenditure(% of government expenditure on education) of Portugal?
Your response must be concise. 5.4. In the year 2010, what is the difference between the Expenditure(% of government expenditure on education) in Iceland and Expenditure(% of government expenditure on education) in Thailand?
Provide a succinct answer. -7.71. In the year 2010, what is the difference between the Expenditure(% of government expenditure on education) of Ireland and Expenditure(% of government expenditure on education) of Portugal?
Your answer should be compact. 8.37. In the year 2010, what is the difference between the Expenditure(% of government expenditure on education) of Ireland and Expenditure(% of government expenditure on education) of Thailand?
Your answer should be compact. -4.74. In the year 2010, what is the difference between the Expenditure(% of government expenditure on education) in Portugal and Expenditure(% of government expenditure on education) in Thailand?
Offer a terse response. -13.11. In the year 2011, what is the difference between the Expenditure(% of government expenditure on education) of Iceland and Expenditure(% of government expenditure on education) of Ireland?
Your answer should be very brief. -2.05. In the year 2011, what is the difference between the Expenditure(% of government expenditure on education) of Iceland and Expenditure(% of government expenditure on education) of Portugal?
Your answer should be very brief. 5.99. In the year 2011, what is the difference between the Expenditure(% of government expenditure on education) of Iceland and Expenditure(% of government expenditure on education) of Thailand?
Offer a terse response. -16.78. In the year 2011, what is the difference between the Expenditure(% of government expenditure on education) in Ireland and Expenditure(% of government expenditure on education) in Portugal?
Your response must be concise. 8.04. In the year 2011, what is the difference between the Expenditure(% of government expenditure on education) of Ireland and Expenditure(% of government expenditure on education) of Thailand?
Give a very brief answer. -14.73. In the year 2011, what is the difference between the Expenditure(% of government expenditure on education) of Portugal and Expenditure(% of government expenditure on education) of Thailand?
Your answer should be compact. -22.77. What is the ratio of the Expenditure(% of government expenditure on education) in Iceland in 2000 to that in 2001?
Provide a succinct answer. 1.07. What is the ratio of the Expenditure(% of government expenditure on education) in Ireland in 2000 to that in 2001?
Ensure brevity in your answer.  0.97. What is the ratio of the Expenditure(% of government expenditure on education) of Portugal in 2000 to that in 2001?
Your answer should be very brief. 0.99. What is the ratio of the Expenditure(% of government expenditure on education) in Thailand in 2000 to that in 2001?
Offer a very short reply. 1. What is the ratio of the Expenditure(% of government expenditure on education) in Iceland in 2000 to that in 2004?
Provide a succinct answer. 1.06. What is the ratio of the Expenditure(% of government expenditure on education) in Ireland in 2000 to that in 2004?
Provide a short and direct response. 0.92. What is the ratio of the Expenditure(% of government expenditure on education) in Portugal in 2000 to that in 2004?
Your answer should be compact. 0.96. What is the ratio of the Expenditure(% of government expenditure on education) of Thailand in 2000 to that in 2004?
Offer a terse response. 1.04. What is the ratio of the Expenditure(% of government expenditure on education) in Iceland in 2000 to that in 2008?
Give a very brief answer. 1.11. What is the ratio of the Expenditure(% of government expenditure on education) in Ireland in 2000 to that in 2008?
Keep it short and to the point. 0.86. What is the ratio of the Expenditure(% of government expenditure on education) of Portugal in 2000 to that in 2008?
Keep it short and to the point. 1.04. What is the ratio of the Expenditure(% of government expenditure on education) in Thailand in 2000 to that in 2008?
Offer a very short reply. 0.71. What is the ratio of the Expenditure(% of government expenditure on education) in Iceland in 2000 to that in 2009?
Make the answer very short. 1.14. What is the ratio of the Expenditure(% of government expenditure on education) of Ireland in 2000 to that in 2009?
Your response must be concise. 0.86. What is the ratio of the Expenditure(% of government expenditure on education) of Portugal in 2000 to that in 2009?
Provide a short and direct response. 1.11. What is the ratio of the Expenditure(% of government expenditure on education) of Thailand in 2000 to that in 2009?
Your answer should be very brief. 0.7. What is the ratio of the Expenditure(% of government expenditure on education) in Iceland in 2000 to that in 2010?
Offer a terse response. 1.14. What is the ratio of the Expenditure(% of government expenditure on education) in Ireland in 2000 to that in 2010?
Make the answer very short. 0.87. What is the ratio of the Expenditure(% of government expenditure on education) of Portugal in 2000 to that in 2010?
Keep it short and to the point. 1.11. What is the ratio of the Expenditure(% of government expenditure on education) of Thailand in 2000 to that in 2010?
Your answer should be very brief. 0.8. What is the ratio of the Expenditure(% of government expenditure on education) of Iceland in 2000 to that in 2011?
Provide a short and direct response. 1.1. What is the ratio of the Expenditure(% of government expenditure on education) of Ireland in 2000 to that in 2011?
Provide a short and direct response. 0.86. What is the ratio of the Expenditure(% of government expenditure on education) in Portugal in 2000 to that in 2011?
Your response must be concise. 1.08. What is the ratio of the Expenditure(% of government expenditure on education) of Thailand in 2000 to that in 2011?
Offer a very short reply. 0.64. What is the ratio of the Expenditure(% of government expenditure on education) in Ireland in 2001 to that in 2004?
Provide a short and direct response. 0.95. What is the ratio of the Expenditure(% of government expenditure on education) in Portugal in 2001 to that in 2004?
Keep it short and to the point. 0.97. What is the ratio of the Expenditure(% of government expenditure on education) of Thailand in 2001 to that in 2004?
Provide a short and direct response. 1.04. What is the ratio of the Expenditure(% of government expenditure on education) in Iceland in 2001 to that in 2008?
Ensure brevity in your answer.  1.03. What is the ratio of the Expenditure(% of government expenditure on education) in Ireland in 2001 to that in 2008?
Keep it short and to the point. 0.89. What is the ratio of the Expenditure(% of government expenditure on education) in Portugal in 2001 to that in 2008?
Ensure brevity in your answer.  1.05. What is the ratio of the Expenditure(% of government expenditure on education) of Thailand in 2001 to that in 2008?
Provide a short and direct response. 0.71. What is the ratio of the Expenditure(% of government expenditure on education) in Iceland in 2001 to that in 2009?
Give a very brief answer. 1.06. What is the ratio of the Expenditure(% of government expenditure on education) in Ireland in 2001 to that in 2009?
Offer a very short reply. 0.89. What is the ratio of the Expenditure(% of government expenditure on education) in Portugal in 2001 to that in 2009?
Provide a short and direct response. 1.12. What is the ratio of the Expenditure(% of government expenditure on education) of Thailand in 2001 to that in 2009?
Give a very brief answer. 0.7. What is the ratio of the Expenditure(% of government expenditure on education) in Iceland in 2001 to that in 2010?
Keep it short and to the point. 1.07. What is the ratio of the Expenditure(% of government expenditure on education) of Ireland in 2001 to that in 2010?
Provide a succinct answer. 0.9. What is the ratio of the Expenditure(% of government expenditure on education) of Portugal in 2001 to that in 2010?
Your answer should be compact. 1.12. What is the ratio of the Expenditure(% of government expenditure on education) in Thailand in 2001 to that in 2010?
Your response must be concise. 0.8. What is the ratio of the Expenditure(% of government expenditure on education) of Iceland in 2001 to that in 2011?
Make the answer very short. 1.02. What is the ratio of the Expenditure(% of government expenditure on education) in Ireland in 2001 to that in 2011?
Offer a terse response. 0.89. What is the ratio of the Expenditure(% of government expenditure on education) in Portugal in 2001 to that in 2011?
Your answer should be compact. 1.09. What is the ratio of the Expenditure(% of government expenditure on education) of Thailand in 2001 to that in 2011?
Offer a very short reply. 0.64. What is the ratio of the Expenditure(% of government expenditure on education) in Iceland in 2004 to that in 2008?
Keep it short and to the point. 1.04. What is the ratio of the Expenditure(% of government expenditure on education) of Ireland in 2004 to that in 2008?
Give a very brief answer. 0.93. What is the ratio of the Expenditure(% of government expenditure on education) of Portugal in 2004 to that in 2008?
Offer a very short reply. 1.08. What is the ratio of the Expenditure(% of government expenditure on education) in Thailand in 2004 to that in 2008?
Your response must be concise. 0.69. What is the ratio of the Expenditure(% of government expenditure on education) in Iceland in 2004 to that in 2009?
Your response must be concise. 1.07. What is the ratio of the Expenditure(% of government expenditure on education) in Ireland in 2004 to that in 2009?
Your answer should be very brief. 0.94. What is the ratio of the Expenditure(% of government expenditure on education) in Portugal in 2004 to that in 2009?
Your response must be concise. 1.16. What is the ratio of the Expenditure(% of government expenditure on education) of Thailand in 2004 to that in 2009?
Give a very brief answer. 0.67. What is the ratio of the Expenditure(% of government expenditure on education) of Iceland in 2004 to that in 2010?
Provide a succinct answer. 1.07. What is the ratio of the Expenditure(% of government expenditure on education) of Ireland in 2004 to that in 2010?
Make the answer very short. 0.95. What is the ratio of the Expenditure(% of government expenditure on education) of Portugal in 2004 to that in 2010?
Your answer should be compact. 1.16. What is the ratio of the Expenditure(% of government expenditure on education) in Thailand in 2004 to that in 2010?
Provide a short and direct response. 0.77. What is the ratio of the Expenditure(% of government expenditure on education) in Iceland in 2004 to that in 2011?
Keep it short and to the point. 1.03. What is the ratio of the Expenditure(% of government expenditure on education) of Ireland in 2004 to that in 2011?
Provide a succinct answer. 0.94. What is the ratio of the Expenditure(% of government expenditure on education) in Portugal in 2004 to that in 2011?
Offer a very short reply. 1.13. What is the ratio of the Expenditure(% of government expenditure on education) in Thailand in 2004 to that in 2011?
Ensure brevity in your answer.  0.61. What is the ratio of the Expenditure(% of government expenditure on education) in Iceland in 2008 to that in 2009?
Provide a short and direct response. 1.02. What is the ratio of the Expenditure(% of government expenditure on education) of Ireland in 2008 to that in 2009?
Your answer should be compact. 1.01. What is the ratio of the Expenditure(% of government expenditure on education) of Portugal in 2008 to that in 2009?
Offer a very short reply. 1.07. What is the ratio of the Expenditure(% of government expenditure on education) in Thailand in 2008 to that in 2009?
Ensure brevity in your answer.  0.98. What is the ratio of the Expenditure(% of government expenditure on education) in Iceland in 2008 to that in 2010?
Provide a short and direct response. 1.03. What is the ratio of the Expenditure(% of government expenditure on education) in Ireland in 2008 to that in 2010?
Ensure brevity in your answer.  1.02. What is the ratio of the Expenditure(% of government expenditure on education) in Portugal in 2008 to that in 2010?
Your answer should be very brief. 1.07. What is the ratio of the Expenditure(% of government expenditure on education) in Thailand in 2008 to that in 2010?
Provide a succinct answer. 1.13. What is the ratio of the Expenditure(% of government expenditure on education) in Portugal in 2008 to that in 2011?
Offer a very short reply. 1.04. What is the ratio of the Expenditure(% of government expenditure on education) in Thailand in 2008 to that in 2011?
Your answer should be compact. 0.89. What is the ratio of the Expenditure(% of government expenditure on education) of Iceland in 2009 to that in 2010?
Your answer should be very brief. 1.01. What is the ratio of the Expenditure(% of government expenditure on education) in Ireland in 2009 to that in 2010?
Offer a terse response. 1.01. What is the ratio of the Expenditure(% of government expenditure on education) in Thailand in 2009 to that in 2010?
Make the answer very short. 1.15. What is the ratio of the Expenditure(% of government expenditure on education) of Iceland in 2009 to that in 2011?
Your answer should be compact. 0.97. What is the ratio of the Expenditure(% of government expenditure on education) in Thailand in 2009 to that in 2011?
Keep it short and to the point. 0.91. What is the ratio of the Expenditure(% of government expenditure on education) of Iceland in 2010 to that in 2011?
Provide a succinct answer. 0.96. What is the ratio of the Expenditure(% of government expenditure on education) in Ireland in 2010 to that in 2011?
Give a very brief answer. 0.99. What is the ratio of the Expenditure(% of government expenditure on education) of Portugal in 2010 to that in 2011?
Provide a succinct answer. 0.97. What is the ratio of the Expenditure(% of government expenditure on education) in Thailand in 2010 to that in 2011?
Keep it short and to the point. 0.79. What is the difference between the highest and the second highest Expenditure(% of government expenditure on education) in Iceland?
Provide a succinct answer. 2.26. What is the difference between the highest and the second highest Expenditure(% of government expenditure on education) in Ireland?
Your response must be concise. 0.2. What is the difference between the highest and the second highest Expenditure(% of government expenditure on education) of Portugal?
Offer a very short reply. 0.95. What is the difference between the highest and the second highest Expenditure(% of government expenditure on education) in Thailand?
Ensure brevity in your answer.  4.31. What is the difference between the highest and the lowest Expenditure(% of government expenditure on education) of Iceland?
Offer a very short reply. 4.64. What is the difference between the highest and the lowest Expenditure(% of government expenditure on education) in Ireland?
Your answer should be compact. 5.12. What is the difference between the highest and the lowest Expenditure(% of government expenditure on education) in Portugal?
Give a very brief answer. 4.29. What is the difference between the highest and the lowest Expenditure(% of government expenditure on education) in Thailand?
Your answer should be compact. 19.48. 